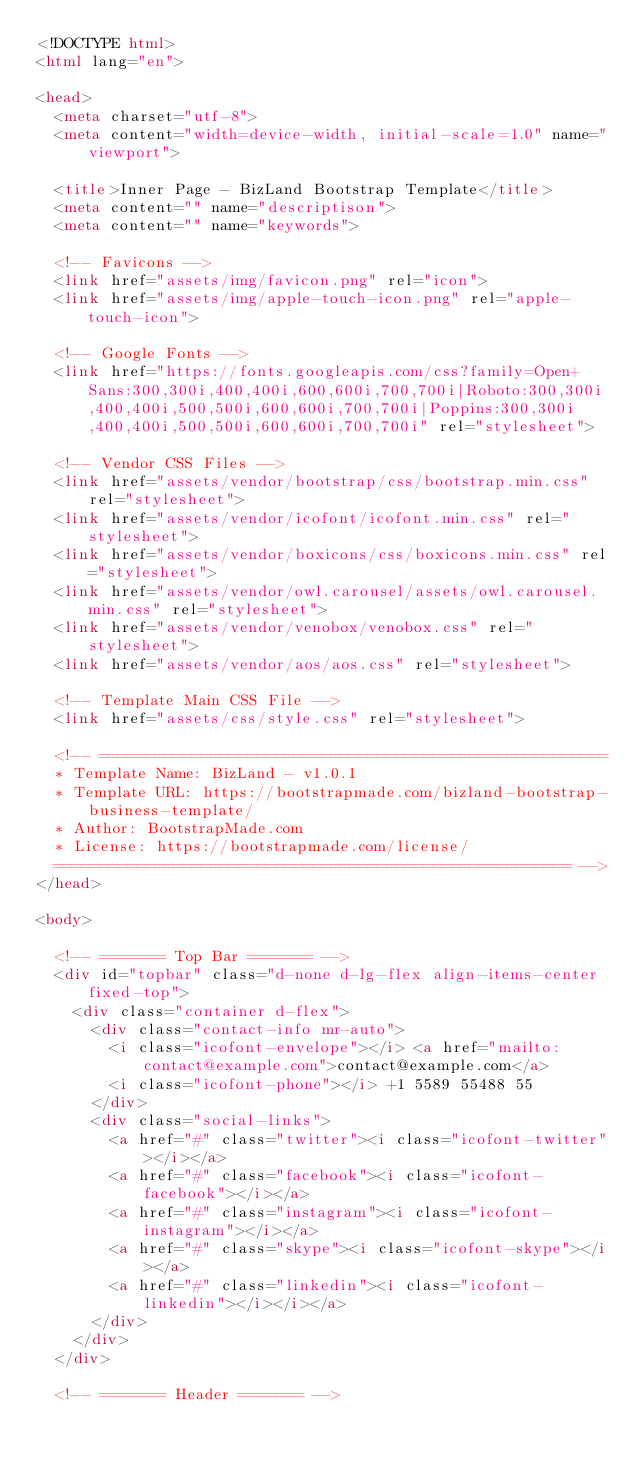<code> <loc_0><loc_0><loc_500><loc_500><_HTML_><!DOCTYPE html>
<html lang="en">

<head>
  <meta charset="utf-8">
  <meta content="width=device-width, initial-scale=1.0" name="viewport">

  <title>Inner Page - BizLand Bootstrap Template</title>
  <meta content="" name="descriptison">
  <meta content="" name="keywords">

  <!-- Favicons -->
  <link href="assets/img/favicon.png" rel="icon">
  <link href="assets/img/apple-touch-icon.png" rel="apple-touch-icon">

  <!-- Google Fonts -->
  <link href="https://fonts.googleapis.com/css?family=Open+Sans:300,300i,400,400i,600,600i,700,700i|Roboto:300,300i,400,400i,500,500i,600,600i,700,700i|Poppins:300,300i,400,400i,500,500i,600,600i,700,700i" rel="stylesheet">

  <!-- Vendor CSS Files -->
  <link href="assets/vendor/bootstrap/css/bootstrap.min.css" rel="stylesheet">
  <link href="assets/vendor/icofont/icofont.min.css" rel="stylesheet">
  <link href="assets/vendor/boxicons/css/boxicons.min.css" rel="stylesheet">
  <link href="assets/vendor/owl.carousel/assets/owl.carousel.min.css" rel="stylesheet">
  <link href="assets/vendor/venobox/venobox.css" rel="stylesheet">
  <link href="assets/vendor/aos/aos.css" rel="stylesheet">

  <!-- Template Main CSS File -->
  <link href="assets/css/style.css" rel="stylesheet">

  <!-- =======================================================
  * Template Name: BizLand - v1.0.1
  * Template URL: https://bootstrapmade.com/bizland-bootstrap-business-template/
  * Author: BootstrapMade.com
  * License: https://bootstrapmade.com/license/
  ======================================================== -->
</head>

<body>

  <!-- ======= Top Bar ======= -->
  <div id="topbar" class="d-none d-lg-flex align-items-center fixed-top">
    <div class="container d-flex">
      <div class="contact-info mr-auto">
        <i class="icofont-envelope"></i> <a href="mailto:contact@example.com">contact@example.com</a>
        <i class="icofont-phone"></i> +1 5589 55488 55
      </div>
      <div class="social-links">
        <a href="#" class="twitter"><i class="icofont-twitter"></i></a>
        <a href="#" class="facebook"><i class="icofont-facebook"></i></a>
        <a href="#" class="instagram"><i class="icofont-instagram"></i></a>
        <a href="#" class="skype"><i class="icofont-skype"></i></a>
        <a href="#" class="linkedin"><i class="icofont-linkedin"></i></i></a>
      </div>
    </div>
  </div>

  <!-- ======= Header ======= --></code> 